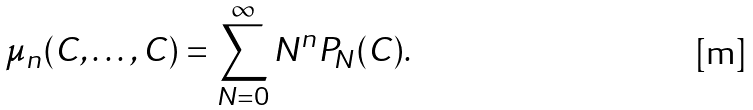Convert formula to latex. <formula><loc_0><loc_0><loc_500><loc_500>\mu _ { n } ( C , \dots , C ) = \sum _ { N = 0 } ^ { \infty } N ^ { n } P _ { N } ( C ) .</formula> 